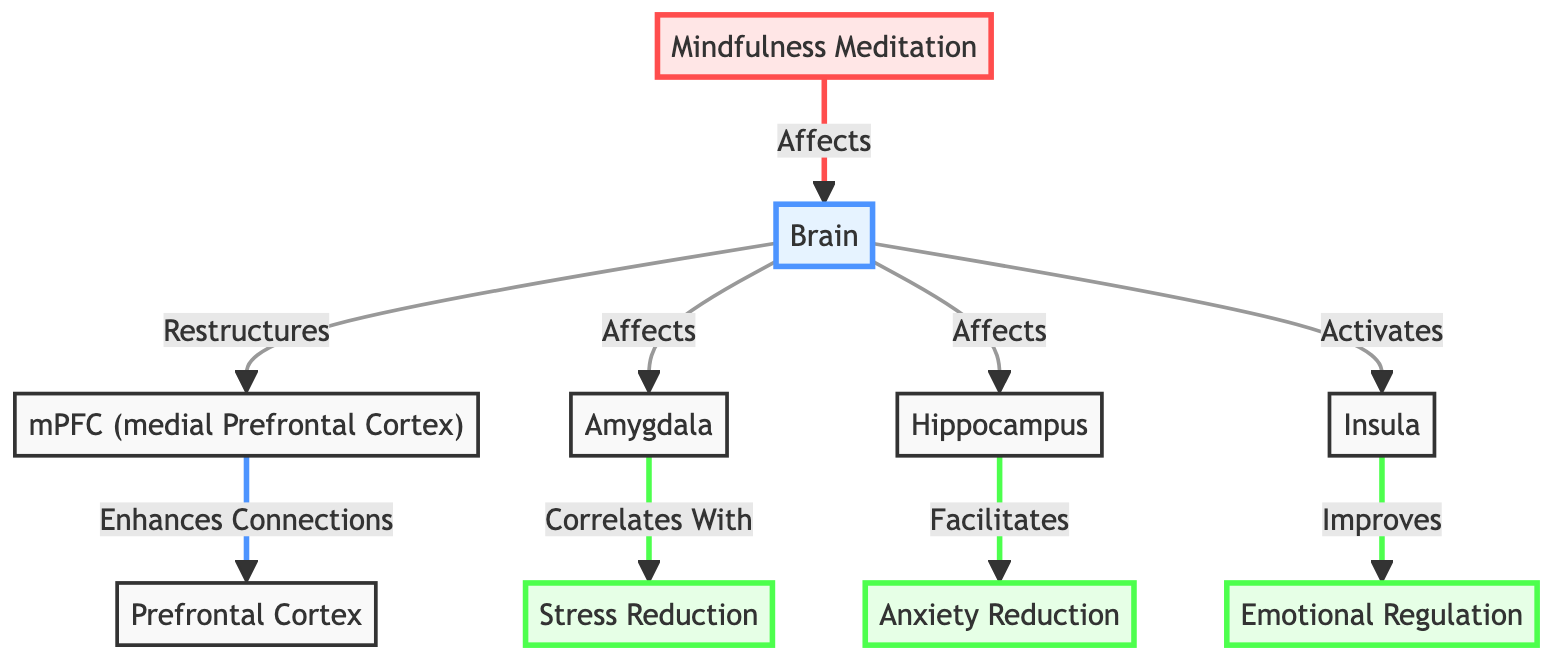What is the main focus of the diagram? The diagram illustrates the impact of mindfulness meditation on the brain and its correlation with reduced stress levels. This can be inferred from the title and connections made in the visual representation.
Answer: Mindfulness Meditation Which brain region is associated with emotional regulation? The insula is explicitly labeled in the diagram with the connection indicating that it improves emotional regulation, showcasing its role in the context of mindfulness meditation.
Answer: Insula How many major brain regions are affected by mindfulness meditation? The diagram connects mindfulness meditation to four major brain regions: mPFC, amygdala, hippocampus, and insula, providing a count of these areas involved.
Answer: Four Which area enhances connections with the prefrontal cortex? The mPFC (medial Prefrontal Cortex) is depicted with a direct link to the prefrontal cortex, indicating that it is the area responsible for enhancing these connections.
Answer: mPFC What correlation does the amygdala have in the context of stress? The diagram indicates that the amygdala correlates with stress reduction. By following the arrows, we find that this specific connection directly links stress reduction to the amygdala's involvement.
Answer: Stress Reduction How does mindfulness meditation affect the hippocampus? According to the diagram, mindfulness meditation facilitates anxiety reduction through its effects on the hippocampus, demonstrating a direct functional outcome of meditation practice.
Answer: Anxiety Reduction What does mindfulness meditation activate in the brain? The diagram shows a direct link from mindfulness meditation to the insula, signifying that it activates this brain region, which is important for emotional processes.
Answer: Insula Which two effects are correlated with changes in the amygdala? The amygdala is shown to correlate with stress reduction and anxiety reduction, indicating that alterations in this region affect both outcomes in the context of mindfulness meditation.
Answer: Stress Reduction, Anxiety Reduction What effect does the mPFC have on the prefrontal cortex? The diagram illustrates that the mPFC enhances connections with the prefrontal cortex, signifying a positive impact it has on building neural pathways in this area.
Answer: Enhances Connections 